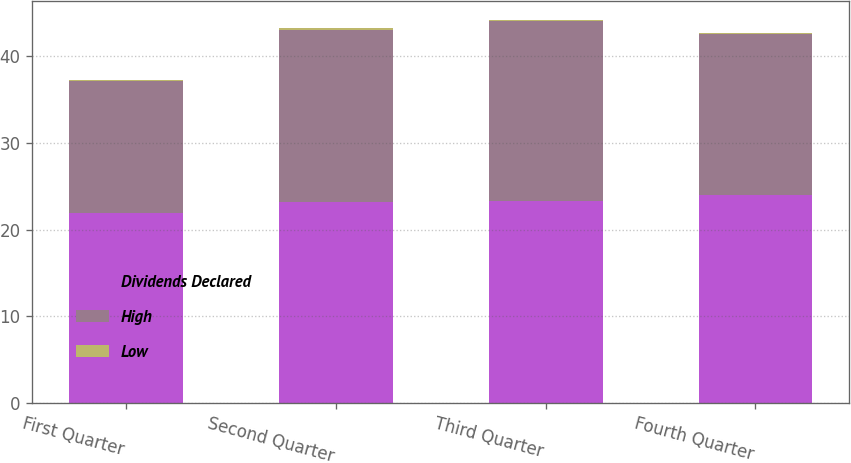Convert chart to OTSL. <chart><loc_0><loc_0><loc_500><loc_500><stacked_bar_chart><ecel><fcel>First Quarter<fcel>Second Quarter<fcel>Third Quarter<fcel>Fourth Quarter<nl><fcel>Dividends Declared<fcel>21.85<fcel>23.22<fcel>23.27<fcel>24.02<nl><fcel>High<fcel>15.19<fcel>19.78<fcel>20.73<fcel>18.51<nl><fcel>Low<fcel>0.14<fcel>0.14<fcel>0.14<fcel>0.14<nl></chart> 